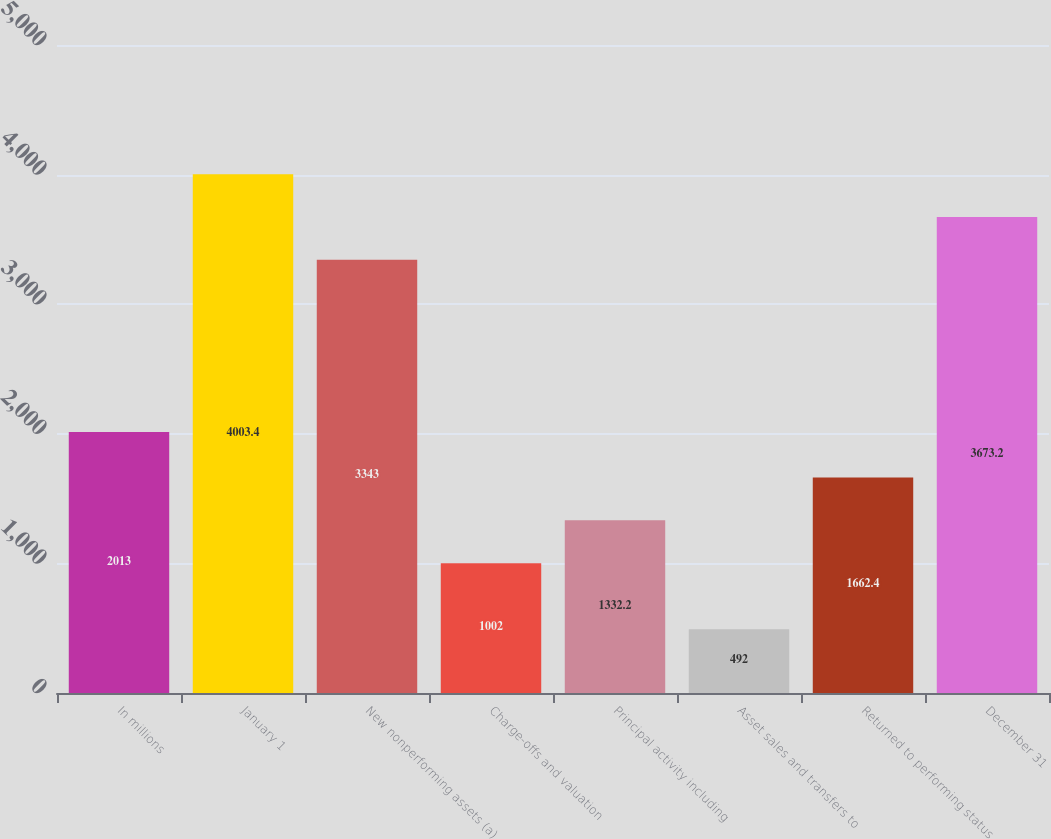Convert chart. <chart><loc_0><loc_0><loc_500><loc_500><bar_chart><fcel>In millions<fcel>January 1<fcel>New nonperforming assets (a)<fcel>Charge-offs and valuation<fcel>Principal activity including<fcel>Asset sales and transfers to<fcel>Returned to performing status<fcel>December 31<nl><fcel>2013<fcel>4003.4<fcel>3343<fcel>1002<fcel>1332.2<fcel>492<fcel>1662.4<fcel>3673.2<nl></chart> 